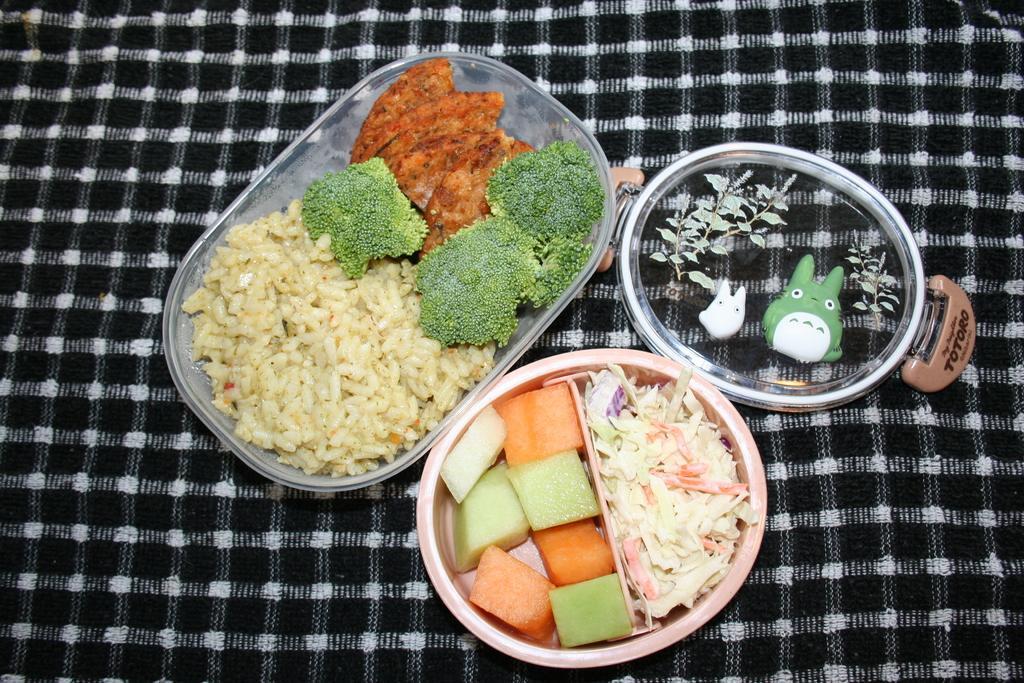Can you describe this image briefly? In this image we can see some food in the boxes containing broccoli, some pieces of fruits and chopped vegetables in it. We can also see a lid of a box which are placed on the surface. 